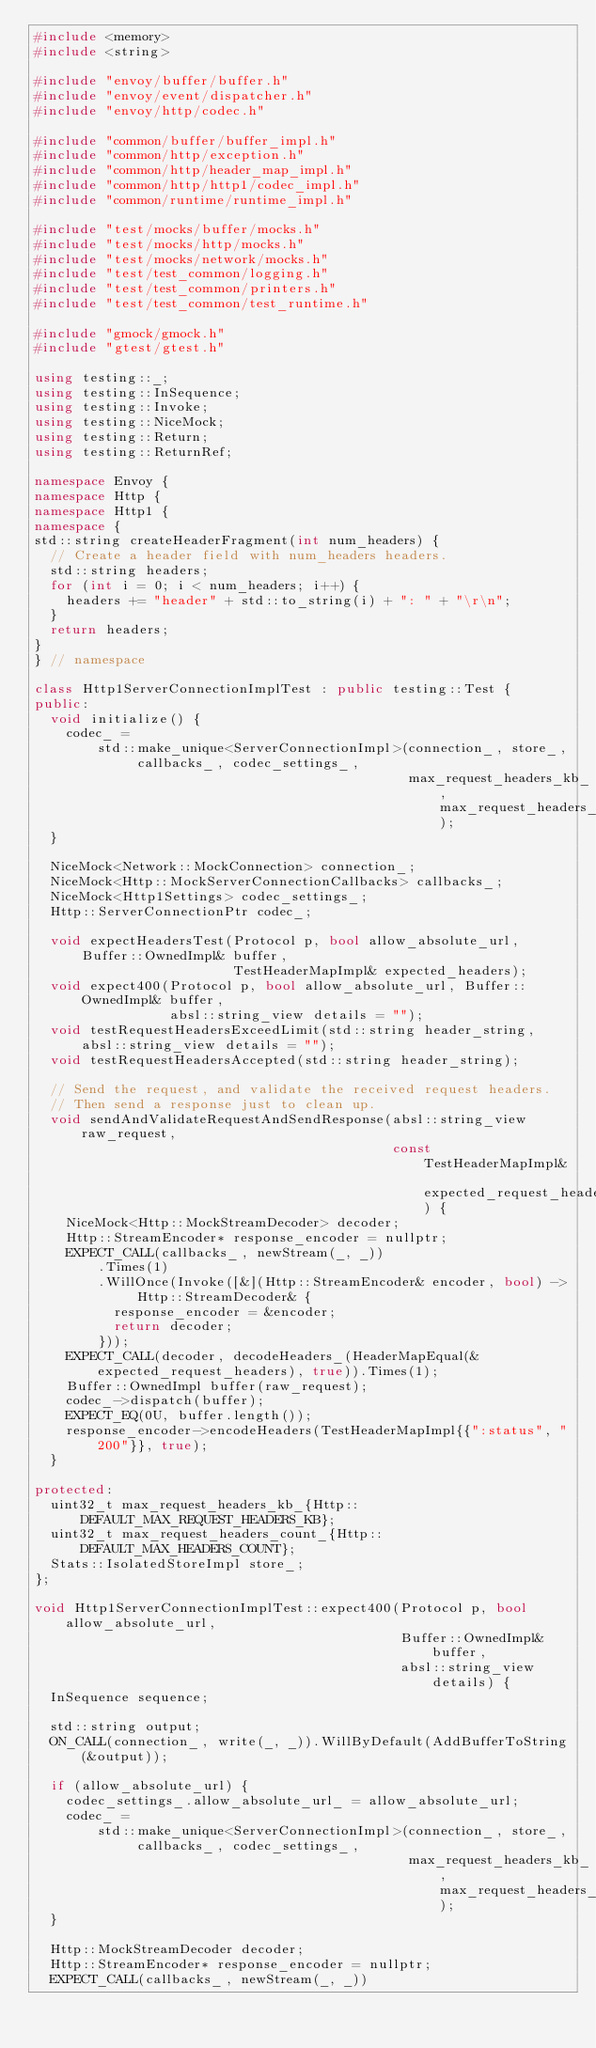<code> <loc_0><loc_0><loc_500><loc_500><_C++_>#include <memory>
#include <string>

#include "envoy/buffer/buffer.h"
#include "envoy/event/dispatcher.h"
#include "envoy/http/codec.h"

#include "common/buffer/buffer_impl.h"
#include "common/http/exception.h"
#include "common/http/header_map_impl.h"
#include "common/http/http1/codec_impl.h"
#include "common/runtime/runtime_impl.h"

#include "test/mocks/buffer/mocks.h"
#include "test/mocks/http/mocks.h"
#include "test/mocks/network/mocks.h"
#include "test/test_common/logging.h"
#include "test/test_common/printers.h"
#include "test/test_common/test_runtime.h"

#include "gmock/gmock.h"
#include "gtest/gtest.h"

using testing::_;
using testing::InSequence;
using testing::Invoke;
using testing::NiceMock;
using testing::Return;
using testing::ReturnRef;

namespace Envoy {
namespace Http {
namespace Http1 {
namespace {
std::string createHeaderFragment(int num_headers) {
  // Create a header field with num_headers headers.
  std::string headers;
  for (int i = 0; i < num_headers; i++) {
    headers += "header" + std::to_string(i) + ": " + "\r\n";
  }
  return headers;
}
} // namespace

class Http1ServerConnectionImplTest : public testing::Test {
public:
  void initialize() {
    codec_ =
        std::make_unique<ServerConnectionImpl>(connection_, store_, callbacks_, codec_settings_,
                                               max_request_headers_kb_, max_request_headers_count_);
  }

  NiceMock<Network::MockConnection> connection_;
  NiceMock<Http::MockServerConnectionCallbacks> callbacks_;
  NiceMock<Http1Settings> codec_settings_;
  Http::ServerConnectionPtr codec_;

  void expectHeadersTest(Protocol p, bool allow_absolute_url, Buffer::OwnedImpl& buffer,
                         TestHeaderMapImpl& expected_headers);
  void expect400(Protocol p, bool allow_absolute_url, Buffer::OwnedImpl& buffer,
                 absl::string_view details = "");
  void testRequestHeadersExceedLimit(std::string header_string, absl::string_view details = "");
  void testRequestHeadersAccepted(std::string header_string);

  // Send the request, and validate the received request headers.
  // Then send a response just to clean up.
  void sendAndValidateRequestAndSendResponse(absl::string_view raw_request,
                                             const TestHeaderMapImpl& expected_request_headers) {
    NiceMock<Http::MockStreamDecoder> decoder;
    Http::StreamEncoder* response_encoder = nullptr;
    EXPECT_CALL(callbacks_, newStream(_, _))
        .Times(1)
        .WillOnce(Invoke([&](Http::StreamEncoder& encoder, bool) -> Http::StreamDecoder& {
          response_encoder = &encoder;
          return decoder;
        }));
    EXPECT_CALL(decoder, decodeHeaders_(HeaderMapEqual(&expected_request_headers), true)).Times(1);
    Buffer::OwnedImpl buffer(raw_request);
    codec_->dispatch(buffer);
    EXPECT_EQ(0U, buffer.length());
    response_encoder->encodeHeaders(TestHeaderMapImpl{{":status", "200"}}, true);
  }

protected:
  uint32_t max_request_headers_kb_{Http::DEFAULT_MAX_REQUEST_HEADERS_KB};
  uint32_t max_request_headers_count_{Http::DEFAULT_MAX_HEADERS_COUNT};
  Stats::IsolatedStoreImpl store_;
};

void Http1ServerConnectionImplTest::expect400(Protocol p, bool allow_absolute_url,
                                              Buffer::OwnedImpl& buffer,
                                              absl::string_view details) {
  InSequence sequence;

  std::string output;
  ON_CALL(connection_, write(_, _)).WillByDefault(AddBufferToString(&output));

  if (allow_absolute_url) {
    codec_settings_.allow_absolute_url_ = allow_absolute_url;
    codec_ =
        std::make_unique<ServerConnectionImpl>(connection_, store_, callbacks_, codec_settings_,
                                               max_request_headers_kb_, max_request_headers_count_);
  }

  Http::MockStreamDecoder decoder;
  Http::StreamEncoder* response_encoder = nullptr;
  EXPECT_CALL(callbacks_, newStream(_, _))</code> 